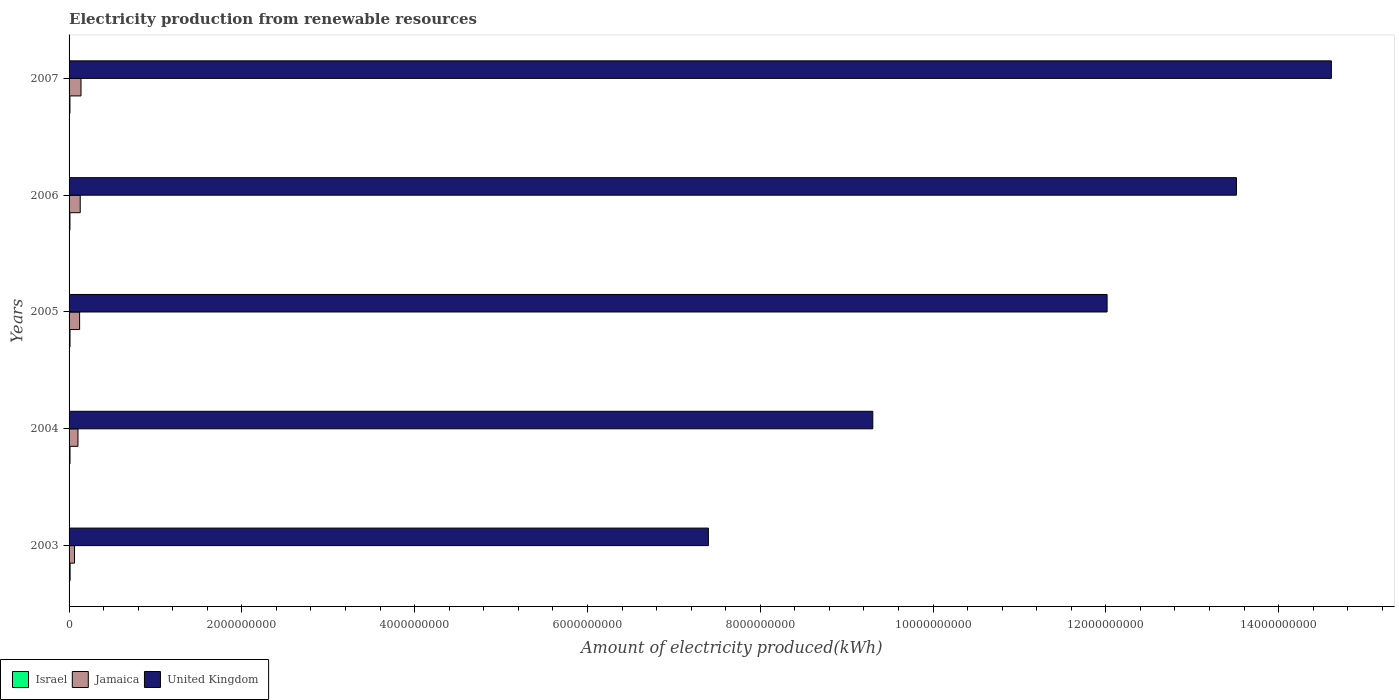How many different coloured bars are there?
Keep it short and to the point. 3. How many groups of bars are there?
Your response must be concise. 5. How many bars are there on the 2nd tick from the bottom?
Your response must be concise. 3. What is the label of the 1st group of bars from the top?
Give a very brief answer. 2007. What is the amount of electricity produced in Israel in 2005?
Offer a terse response. 1.10e+07. Across all years, what is the maximum amount of electricity produced in Jamaica?
Provide a short and direct response. 1.38e+08. Across all years, what is the minimum amount of electricity produced in Israel?
Provide a short and direct response. 1.00e+07. In which year was the amount of electricity produced in United Kingdom maximum?
Your answer should be very brief. 2007. What is the total amount of electricity produced in Jamaica in the graph?
Give a very brief answer. 5.55e+08. What is the difference between the amount of electricity produced in United Kingdom in 2003 and that in 2007?
Give a very brief answer. -7.21e+09. What is the difference between the amount of electricity produced in Jamaica in 2006 and the amount of electricity produced in United Kingdom in 2003?
Make the answer very short. -7.27e+09. What is the average amount of electricity produced in Israel per year?
Offer a terse response. 1.08e+07. In the year 2004, what is the difference between the amount of electricity produced in Jamaica and amount of electricity produced in United Kingdom?
Provide a short and direct response. -9.20e+09. What is the ratio of the amount of electricity produced in United Kingdom in 2005 to that in 2007?
Make the answer very short. 0.82. Is the amount of electricity produced in Israel in 2003 less than that in 2006?
Give a very brief answer. No. Is the difference between the amount of electricity produced in Jamaica in 2004 and 2005 greater than the difference between the amount of electricity produced in United Kingdom in 2004 and 2005?
Make the answer very short. Yes. What is the difference between the highest and the second highest amount of electricity produced in Jamaica?
Offer a terse response. 9.00e+06. What is the difference between the highest and the lowest amount of electricity produced in Jamaica?
Provide a succinct answer. 7.50e+07. In how many years, is the amount of electricity produced in Jamaica greater than the average amount of electricity produced in Jamaica taken over all years?
Offer a very short reply. 3. Is the sum of the amount of electricity produced in United Kingdom in 2005 and 2006 greater than the maximum amount of electricity produced in Israel across all years?
Provide a short and direct response. Yes. Is it the case that in every year, the sum of the amount of electricity produced in Jamaica and amount of electricity produced in United Kingdom is greater than the amount of electricity produced in Israel?
Provide a short and direct response. Yes. Are all the bars in the graph horizontal?
Offer a very short reply. Yes. Does the graph contain grids?
Your answer should be very brief. No. Where does the legend appear in the graph?
Your answer should be very brief. Bottom left. How many legend labels are there?
Provide a short and direct response. 3. What is the title of the graph?
Offer a very short reply. Electricity production from renewable resources. Does "Caribbean small states" appear as one of the legend labels in the graph?
Keep it short and to the point. No. What is the label or title of the X-axis?
Your answer should be compact. Amount of electricity produced(kWh). What is the label or title of the Y-axis?
Your answer should be compact. Years. What is the Amount of electricity produced(kWh) in Israel in 2003?
Your response must be concise. 1.20e+07. What is the Amount of electricity produced(kWh) of Jamaica in 2003?
Provide a short and direct response. 6.30e+07. What is the Amount of electricity produced(kWh) of United Kingdom in 2003?
Your answer should be very brief. 7.40e+09. What is the Amount of electricity produced(kWh) in Israel in 2004?
Ensure brevity in your answer.  1.10e+07. What is the Amount of electricity produced(kWh) in Jamaica in 2004?
Ensure brevity in your answer.  1.03e+08. What is the Amount of electricity produced(kWh) of United Kingdom in 2004?
Your answer should be very brief. 9.30e+09. What is the Amount of electricity produced(kWh) of Israel in 2005?
Offer a terse response. 1.10e+07. What is the Amount of electricity produced(kWh) of Jamaica in 2005?
Keep it short and to the point. 1.22e+08. What is the Amount of electricity produced(kWh) of United Kingdom in 2005?
Make the answer very short. 1.20e+1. What is the Amount of electricity produced(kWh) in Jamaica in 2006?
Your response must be concise. 1.29e+08. What is the Amount of electricity produced(kWh) of United Kingdom in 2006?
Make the answer very short. 1.35e+1. What is the Amount of electricity produced(kWh) in Jamaica in 2007?
Give a very brief answer. 1.38e+08. What is the Amount of electricity produced(kWh) of United Kingdom in 2007?
Your answer should be very brief. 1.46e+1. Across all years, what is the maximum Amount of electricity produced(kWh) in Israel?
Offer a very short reply. 1.20e+07. Across all years, what is the maximum Amount of electricity produced(kWh) in Jamaica?
Ensure brevity in your answer.  1.38e+08. Across all years, what is the maximum Amount of electricity produced(kWh) of United Kingdom?
Make the answer very short. 1.46e+1. Across all years, what is the minimum Amount of electricity produced(kWh) of Jamaica?
Keep it short and to the point. 6.30e+07. Across all years, what is the minimum Amount of electricity produced(kWh) of United Kingdom?
Give a very brief answer. 7.40e+09. What is the total Amount of electricity produced(kWh) of Israel in the graph?
Provide a short and direct response. 5.40e+07. What is the total Amount of electricity produced(kWh) of Jamaica in the graph?
Offer a terse response. 5.55e+08. What is the total Amount of electricity produced(kWh) of United Kingdom in the graph?
Your answer should be compact. 5.68e+1. What is the difference between the Amount of electricity produced(kWh) of Jamaica in 2003 and that in 2004?
Make the answer very short. -4.00e+07. What is the difference between the Amount of electricity produced(kWh) in United Kingdom in 2003 and that in 2004?
Offer a terse response. -1.90e+09. What is the difference between the Amount of electricity produced(kWh) of Israel in 2003 and that in 2005?
Keep it short and to the point. 1.00e+06. What is the difference between the Amount of electricity produced(kWh) of Jamaica in 2003 and that in 2005?
Your answer should be very brief. -5.90e+07. What is the difference between the Amount of electricity produced(kWh) of United Kingdom in 2003 and that in 2005?
Make the answer very short. -4.62e+09. What is the difference between the Amount of electricity produced(kWh) of Israel in 2003 and that in 2006?
Make the answer very short. 2.00e+06. What is the difference between the Amount of electricity produced(kWh) in Jamaica in 2003 and that in 2006?
Ensure brevity in your answer.  -6.60e+07. What is the difference between the Amount of electricity produced(kWh) in United Kingdom in 2003 and that in 2006?
Provide a succinct answer. -6.11e+09. What is the difference between the Amount of electricity produced(kWh) in Israel in 2003 and that in 2007?
Ensure brevity in your answer.  2.00e+06. What is the difference between the Amount of electricity produced(kWh) of Jamaica in 2003 and that in 2007?
Provide a short and direct response. -7.50e+07. What is the difference between the Amount of electricity produced(kWh) of United Kingdom in 2003 and that in 2007?
Make the answer very short. -7.21e+09. What is the difference between the Amount of electricity produced(kWh) in Israel in 2004 and that in 2005?
Provide a succinct answer. 0. What is the difference between the Amount of electricity produced(kWh) in Jamaica in 2004 and that in 2005?
Ensure brevity in your answer.  -1.90e+07. What is the difference between the Amount of electricity produced(kWh) of United Kingdom in 2004 and that in 2005?
Your response must be concise. -2.71e+09. What is the difference between the Amount of electricity produced(kWh) in Jamaica in 2004 and that in 2006?
Your answer should be very brief. -2.60e+07. What is the difference between the Amount of electricity produced(kWh) of United Kingdom in 2004 and that in 2006?
Offer a terse response. -4.21e+09. What is the difference between the Amount of electricity produced(kWh) in Jamaica in 2004 and that in 2007?
Your answer should be compact. -3.50e+07. What is the difference between the Amount of electricity produced(kWh) in United Kingdom in 2004 and that in 2007?
Offer a terse response. -5.31e+09. What is the difference between the Amount of electricity produced(kWh) of Jamaica in 2005 and that in 2006?
Make the answer very short. -7.00e+06. What is the difference between the Amount of electricity produced(kWh) of United Kingdom in 2005 and that in 2006?
Provide a succinct answer. -1.50e+09. What is the difference between the Amount of electricity produced(kWh) in Israel in 2005 and that in 2007?
Keep it short and to the point. 1.00e+06. What is the difference between the Amount of electricity produced(kWh) in Jamaica in 2005 and that in 2007?
Your response must be concise. -1.60e+07. What is the difference between the Amount of electricity produced(kWh) of United Kingdom in 2005 and that in 2007?
Your response must be concise. -2.60e+09. What is the difference between the Amount of electricity produced(kWh) in Israel in 2006 and that in 2007?
Keep it short and to the point. 0. What is the difference between the Amount of electricity produced(kWh) of Jamaica in 2006 and that in 2007?
Provide a short and direct response. -9.00e+06. What is the difference between the Amount of electricity produced(kWh) in United Kingdom in 2006 and that in 2007?
Offer a terse response. -1.10e+09. What is the difference between the Amount of electricity produced(kWh) of Israel in 2003 and the Amount of electricity produced(kWh) of Jamaica in 2004?
Ensure brevity in your answer.  -9.10e+07. What is the difference between the Amount of electricity produced(kWh) in Israel in 2003 and the Amount of electricity produced(kWh) in United Kingdom in 2004?
Offer a very short reply. -9.29e+09. What is the difference between the Amount of electricity produced(kWh) of Jamaica in 2003 and the Amount of electricity produced(kWh) of United Kingdom in 2004?
Offer a terse response. -9.24e+09. What is the difference between the Amount of electricity produced(kWh) of Israel in 2003 and the Amount of electricity produced(kWh) of Jamaica in 2005?
Provide a short and direct response. -1.10e+08. What is the difference between the Amount of electricity produced(kWh) of Israel in 2003 and the Amount of electricity produced(kWh) of United Kingdom in 2005?
Your answer should be very brief. -1.20e+1. What is the difference between the Amount of electricity produced(kWh) of Jamaica in 2003 and the Amount of electricity produced(kWh) of United Kingdom in 2005?
Provide a short and direct response. -1.20e+1. What is the difference between the Amount of electricity produced(kWh) in Israel in 2003 and the Amount of electricity produced(kWh) in Jamaica in 2006?
Ensure brevity in your answer.  -1.17e+08. What is the difference between the Amount of electricity produced(kWh) of Israel in 2003 and the Amount of electricity produced(kWh) of United Kingdom in 2006?
Make the answer very short. -1.35e+1. What is the difference between the Amount of electricity produced(kWh) of Jamaica in 2003 and the Amount of electricity produced(kWh) of United Kingdom in 2006?
Make the answer very short. -1.34e+1. What is the difference between the Amount of electricity produced(kWh) of Israel in 2003 and the Amount of electricity produced(kWh) of Jamaica in 2007?
Provide a succinct answer. -1.26e+08. What is the difference between the Amount of electricity produced(kWh) of Israel in 2003 and the Amount of electricity produced(kWh) of United Kingdom in 2007?
Ensure brevity in your answer.  -1.46e+1. What is the difference between the Amount of electricity produced(kWh) in Jamaica in 2003 and the Amount of electricity produced(kWh) in United Kingdom in 2007?
Offer a very short reply. -1.45e+1. What is the difference between the Amount of electricity produced(kWh) of Israel in 2004 and the Amount of electricity produced(kWh) of Jamaica in 2005?
Provide a succinct answer. -1.11e+08. What is the difference between the Amount of electricity produced(kWh) in Israel in 2004 and the Amount of electricity produced(kWh) in United Kingdom in 2005?
Provide a succinct answer. -1.20e+1. What is the difference between the Amount of electricity produced(kWh) in Jamaica in 2004 and the Amount of electricity produced(kWh) in United Kingdom in 2005?
Ensure brevity in your answer.  -1.19e+1. What is the difference between the Amount of electricity produced(kWh) in Israel in 2004 and the Amount of electricity produced(kWh) in Jamaica in 2006?
Give a very brief answer. -1.18e+08. What is the difference between the Amount of electricity produced(kWh) in Israel in 2004 and the Amount of electricity produced(kWh) in United Kingdom in 2006?
Provide a succinct answer. -1.35e+1. What is the difference between the Amount of electricity produced(kWh) in Jamaica in 2004 and the Amount of electricity produced(kWh) in United Kingdom in 2006?
Make the answer very short. -1.34e+1. What is the difference between the Amount of electricity produced(kWh) of Israel in 2004 and the Amount of electricity produced(kWh) of Jamaica in 2007?
Make the answer very short. -1.27e+08. What is the difference between the Amount of electricity produced(kWh) in Israel in 2004 and the Amount of electricity produced(kWh) in United Kingdom in 2007?
Your answer should be compact. -1.46e+1. What is the difference between the Amount of electricity produced(kWh) in Jamaica in 2004 and the Amount of electricity produced(kWh) in United Kingdom in 2007?
Give a very brief answer. -1.45e+1. What is the difference between the Amount of electricity produced(kWh) of Israel in 2005 and the Amount of electricity produced(kWh) of Jamaica in 2006?
Provide a succinct answer. -1.18e+08. What is the difference between the Amount of electricity produced(kWh) in Israel in 2005 and the Amount of electricity produced(kWh) in United Kingdom in 2006?
Your answer should be compact. -1.35e+1. What is the difference between the Amount of electricity produced(kWh) of Jamaica in 2005 and the Amount of electricity produced(kWh) of United Kingdom in 2006?
Make the answer very short. -1.34e+1. What is the difference between the Amount of electricity produced(kWh) in Israel in 2005 and the Amount of electricity produced(kWh) in Jamaica in 2007?
Ensure brevity in your answer.  -1.27e+08. What is the difference between the Amount of electricity produced(kWh) of Israel in 2005 and the Amount of electricity produced(kWh) of United Kingdom in 2007?
Keep it short and to the point. -1.46e+1. What is the difference between the Amount of electricity produced(kWh) of Jamaica in 2005 and the Amount of electricity produced(kWh) of United Kingdom in 2007?
Your response must be concise. -1.45e+1. What is the difference between the Amount of electricity produced(kWh) of Israel in 2006 and the Amount of electricity produced(kWh) of Jamaica in 2007?
Offer a very short reply. -1.28e+08. What is the difference between the Amount of electricity produced(kWh) in Israel in 2006 and the Amount of electricity produced(kWh) in United Kingdom in 2007?
Ensure brevity in your answer.  -1.46e+1. What is the difference between the Amount of electricity produced(kWh) of Jamaica in 2006 and the Amount of electricity produced(kWh) of United Kingdom in 2007?
Give a very brief answer. -1.45e+1. What is the average Amount of electricity produced(kWh) in Israel per year?
Offer a terse response. 1.08e+07. What is the average Amount of electricity produced(kWh) in Jamaica per year?
Give a very brief answer. 1.11e+08. What is the average Amount of electricity produced(kWh) in United Kingdom per year?
Provide a short and direct response. 1.14e+1. In the year 2003, what is the difference between the Amount of electricity produced(kWh) in Israel and Amount of electricity produced(kWh) in Jamaica?
Provide a short and direct response. -5.10e+07. In the year 2003, what is the difference between the Amount of electricity produced(kWh) in Israel and Amount of electricity produced(kWh) in United Kingdom?
Provide a succinct answer. -7.39e+09. In the year 2003, what is the difference between the Amount of electricity produced(kWh) in Jamaica and Amount of electricity produced(kWh) in United Kingdom?
Provide a succinct answer. -7.34e+09. In the year 2004, what is the difference between the Amount of electricity produced(kWh) in Israel and Amount of electricity produced(kWh) in Jamaica?
Your answer should be compact. -9.20e+07. In the year 2004, what is the difference between the Amount of electricity produced(kWh) in Israel and Amount of electricity produced(kWh) in United Kingdom?
Ensure brevity in your answer.  -9.29e+09. In the year 2004, what is the difference between the Amount of electricity produced(kWh) in Jamaica and Amount of electricity produced(kWh) in United Kingdom?
Offer a terse response. -9.20e+09. In the year 2005, what is the difference between the Amount of electricity produced(kWh) in Israel and Amount of electricity produced(kWh) in Jamaica?
Provide a succinct answer. -1.11e+08. In the year 2005, what is the difference between the Amount of electricity produced(kWh) in Israel and Amount of electricity produced(kWh) in United Kingdom?
Provide a short and direct response. -1.20e+1. In the year 2005, what is the difference between the Amount of electricity produced(kWh) in Jamaica and Amount of electricity produced(kWh) in United Kingdom?
Provide a short and direct response. -1.19e+1. In the year 2006, what is the difference between the Amount of electricity produced(kWh) in Israel and Amount of electricity produced(kWh) in Jamaica?
Your answer should be compact. -1.19e+08. In the year 2006, what is the difference between the Amount of electricity produced(kWh) in Israel and Amount of electricity produced(kWh) in United Kingdom?
Offer a very short reply. -1.35e+1. In the year 2006, what is the difference between the Amount of electricity produced(kWh) in Jamaica and Amount of electricity produced(kWh) in United Kingdom?
Your response must be concise. -1.34e+1. In the year 2007, what is the difference between the Amount of electricity produced(kWh) in Israel and Amount of electricity produced(kWh) in Jamaica?
Your answer should be very brief. -1.28e+08. In the year 2007, what is the difference between the Amount of electricity produced(kWh) of Israel and Amount of electricity produced(kWh) of United Kingdom?
Ensure brevity in your answer.  -1.46e+1. In the year 2007, what is the difference between the Amount of electricity produced(kWh) of Jamaica and Amount of electricity produced(kWh) of United Kingdom?
Offer a very short reply. -1.45e+1. What is the ratio of the Amount of electricity produced(kWh) of Jamaica in 2003 to that in 2004?
Offer a very short reply. 0.61. What is the ratio of the Amount of electricity produced(kWh) in United Kingdom in 2003 to that in 2004?
Your answer should be compact. 0.8. What is the ratio of the Amount of electricity produced(kWh) of Israel in 2003 to that in 2005?
Keep it short and to the point. 1.09. What is the ratio of the Amount of electricity produced(kWh) in Jamaica in 2003 to that in 2005?
Make the answer very short. 0.52. What is the ratio of the Amount of electricity produced(kWh) in United Kingdom in 2003 to that in 2005?
Make the answer very short. 0.62. What is the ratio of the Amount of electricity produced(kWh) of Israel in 2003 to that in 2006?
Give a very brief answer. 1.2. What is the ratio of the Amount of electricity produced(kWh) of Jamaica in 2003 to that in 2006?
Offer a very short reply. 0.49. What is the ratio of the Amount of electricity produced(kWh) of United Kingdom in 2003 to that in 2006?
Ensure brevity in your answer.  0.55. What is the ratio of the Amount of electricity produced(kWh) in Israel in 2003 to that in 2007?
Your response must be concise. 1.2. What is the ratio of the Amount of electricity produced(kWh) of Jamaica in 2003 to that in 2007?
Make the answer very short. 0.46. What is the ratio of the Amount of electricity produced(kWh) of United Kingdom in 2003 to that in 2007?
Your answer should be compact. 0.51. What is the ratio of the Amount of electricity produced(kWh) in Israel in 2004 to that in 2005?
Your answer should be compact. 1. What is the ratio of the Amount of electricity produced(kWh) in Jamaica in 2004 to that in 2005?
Make the answer very short. 0.84. What is the ratio of the Amount of electricity produced(kWh) of United Kingdom in 2004 to that in 2005?
Your answer should be very brief. 0.77. What is the ratio of the Amount of electricity produced(kWh) of Israel in 2004 to that in 2006?
Your answer should be compact. 1.1. What is the ratio of the Amount of electricity produced(kWh) of Jamaica in 2004 to that in 2006?
Ensure brevity in your answer.  0.8. What is the ratio of the Amount of electricity produced(kWh) of United Kingdom in 2004 to that in 2006?
Offer a very short reply. 0.69. What is the ratio of the Amount of electricity produced(kWh) of Israel in 2004 to that in 2007?
Your response must be concise. 1.1. What is the ratio of the Amount of electricity produced(kWh) in Jamaica in 2004 to that in 2007?
Make the answer very short. 0.75. What is the ratio of the Amount of electricity produced(kWh) in United Kingdom in 2004 to that in 2007?
Offer a terse response. 0.64. What is the ratio of the Amount of electricity produced(kWh) of Israel in 2005 to that in 2006?
Make the answer very short. 1.1. What is the ratio of the Amount of electricity produced(kWh) of Jamaica in 2005 to that in 2006?
Offer a very short reply. 0.95. What is the ratio of the Amount of electricity produced(kWh) of United Kingdom in 2005 to that in 2006?
Provide a short and direct response. 0.89. What is the ratio of the Amount of electricity produced(kWh) of Israel in 2005 to that in 2007?
Your answer should be very brief. 1.1. What is the ratio of the Amount of electricity produced(kWh) in Jamaica in 2005 to that in 2007?
Give a very brief answer. 0.88. What is the ratio of the Amount of electricity produced(kWh) in United Kingdom in 2005 to that in 2007?
Make the answer very short. 0.82. What is the ratio of the Amount of electricity produced(kWh) of Jamaica in 2006 to that in 2007?
Provide a succinct answer. 0.93. What is the ratio of the Amount of electricity produced(kWh) in United Kingdom in 2006 to that in 2007?
Provide a short and direct response. 0.92. What is the difference between the highest and the second highest Amount of electricity produced(kWh) in Israel?
Make the answer very short. 1.00e+06. What is the difference between the highest and the second highest Amount of electricity produced(kWh) of Jamaica?
Make the answer very short. 9.00e+06. What is the difference between the highest and the second highest Amount of electricity produced(kWh) of United Kingdom?
Make the answer very short. 1.10e+09. What is the difference between the highest and the lowest Amount of electricity produced(kWh) of Jamaica?
Your answer should be very brief. 7.50e+07. What is the difference between the highest and the lowest Amount of electricity produced(kWh) in United Kingdom?
Make the answer very short. 7.21e+09. 